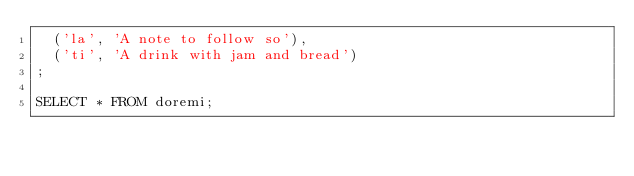<code> <loc_0><loc_0><loc_500><loc_500><_SQL_>  ('la', 'A note to follow so'),
  ('ti', 'A drink with jam and bread')
;

SELECT * FROM doremi;
</code> 